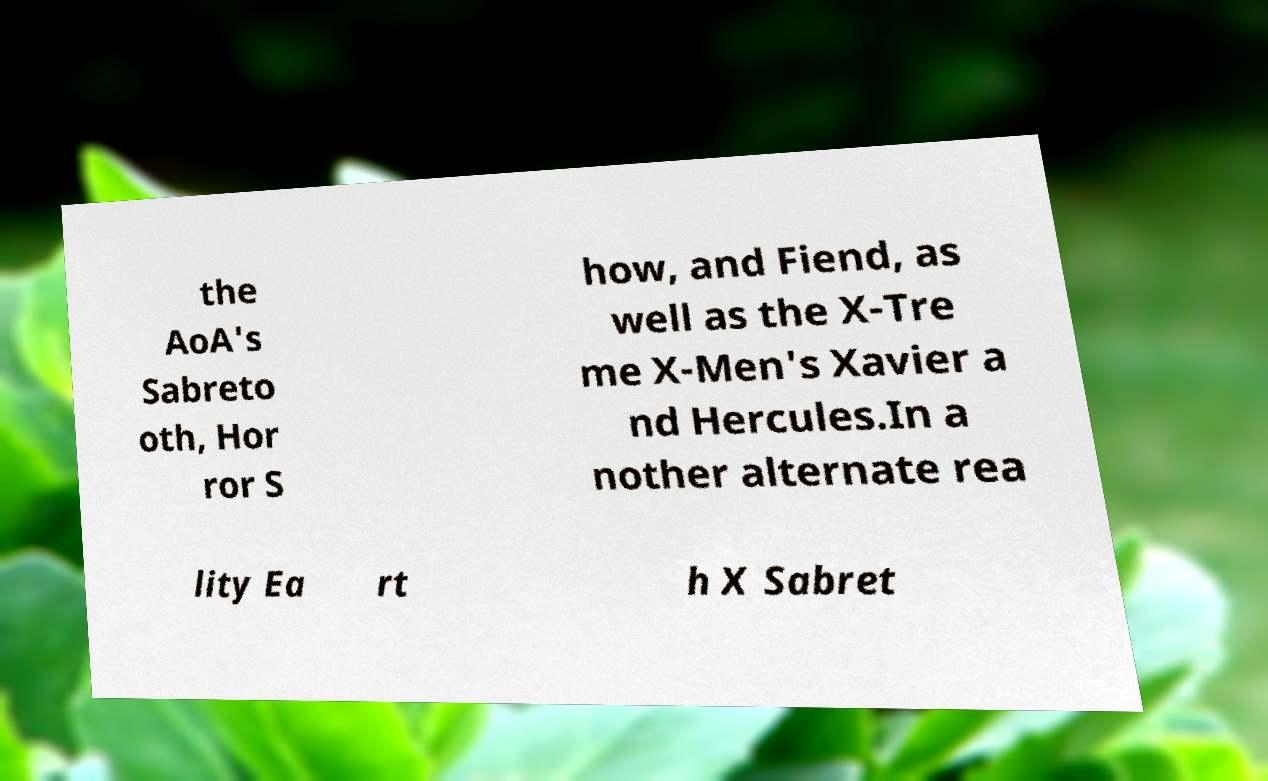For documentation purposes, I need the text within this image transcribed. Could you provide that? the AoA's Sabreto oth, Hor ror S how, and Fiend, as well as the X-Tre me X-Men's Xavier a nd Hercules.In a nother alternate rea lity Ea rt h X Sabret 